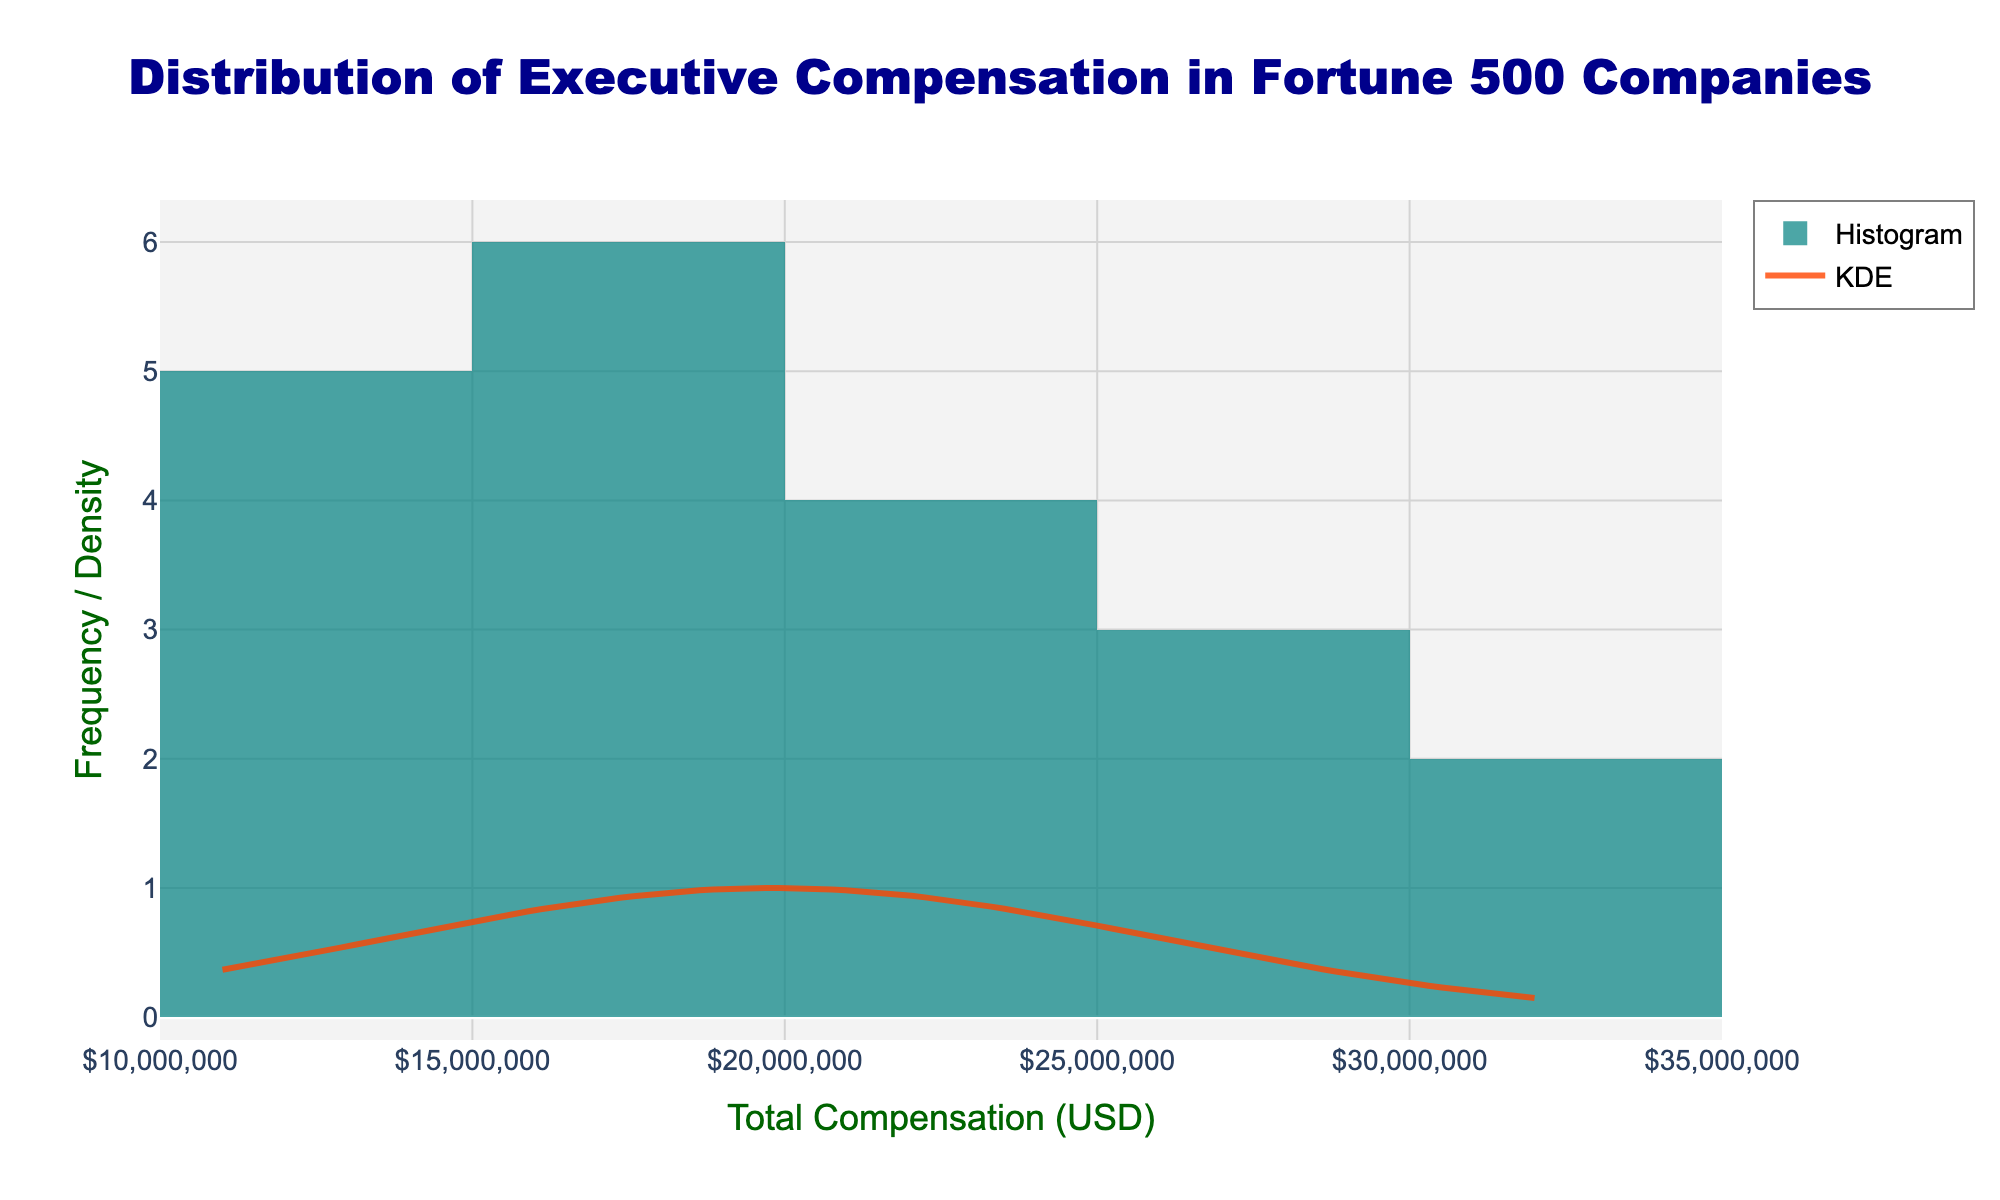What is the title of the plot? The title can be found at the top center of the plot. It is represented in a large, bold font, making it easily noticeable. The title gives a summary of what the plot represents.
Answer: Distribution of Executive Compensation in Fortune 500 Companies What are the x-axis and y-axis titles? These labels indicate what the axes represent. The x-axis title is positioned horizontally below the x-axis, while the y-axis title is vertically aligned next to the y-axis.
Answer: Total Compensation (USD) and Frequency / Density How many bins are there in the histogram? The number of bins in the histogram can be counted by looking at the individual bars. Each bin represents a range of compensation values.
Answer: 10 What is the color of the histogram bars? The color of the histogram bars is a visual element that represents the frequency of compensation ranges. The bars have a semi-transparent teal color.
Answer: Teal What color is the KDE line? The KDE line is represented by a smooth curve line, which is colored differently from the histogram bars to distinguish it. It uses a bold and distinct color for easy visualization.
Answer: Orange Which compensation value has the highest frequency in the histogram? To determine the highest frequency, look for the tallest bar in the histogram. The compensation value corresponding to this bar's center represents the range with the highest frequency.
Answer: $20,000,000 What is the range of executive compensations displayed in the plot? The range can be identified by looking at the minimum and maximum values on the x-axis, which shows the distribution of compensations.
Answer: $11,000,000 to $32,000,000 How many companies have executive compensations above $25,000,000? This requires counting the bins that fall above the $25,000,000 mark and summing their frequencies. These bins represent the executive compensations that exceed the given threshold.
Answer: 2 What is the mean value of executive compensation based on the KDE line? The mean value can often be estimated from the peak of the KDE line, as it generally aligns with the normal distribution's central tendency.
Answer: Approximately $20,000,000 What is the shape of the distribution according to the KDE plot? The shape of the distribution is indicated by the KDE line, which provides a smooth estimate of the density. It highlights the style of the distribution whether it is normal, skewed, etc.
Answer: Approximately normal distribution Which companies fall within the lowest compensation range depicted in the histogram? Identify the lowest bin in the histogram and cross-reference those values with the data to determine which companies have the lowest compensations.
Answer: Kroger and Costco 